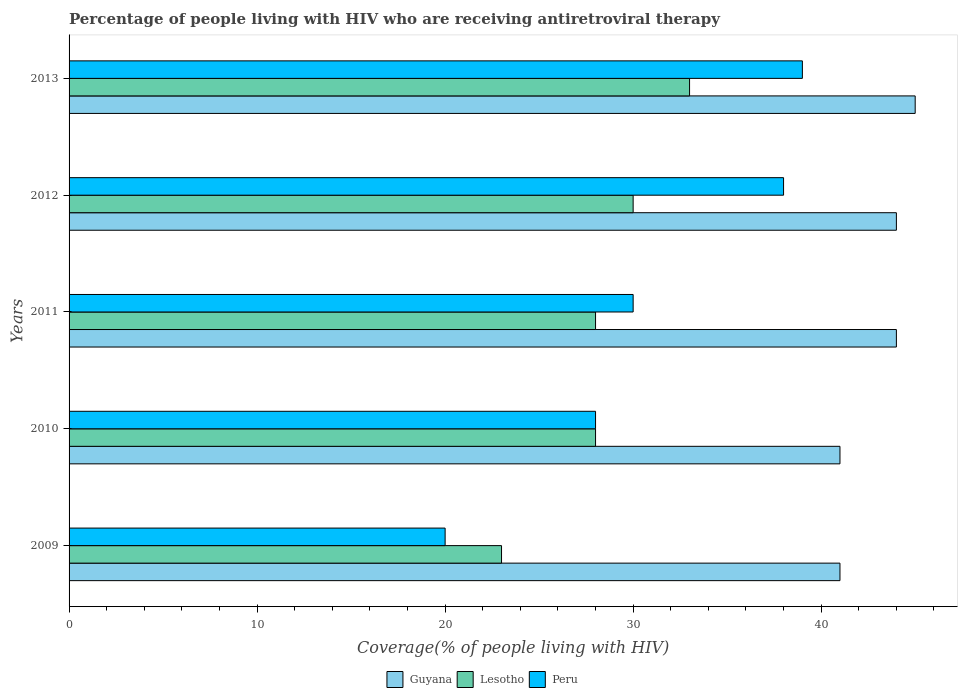How many different coloured bars are there?
Offer a very short reply. 3. What is the label of the 5th group of bars from the top?
Your answer should be compact. 2009. In how many cases, is the number of bars for a given year not equal to the number of legend labels?
Offer a terse response. 0. What is the percentage of the HIV infected people who are receiving antiretroviral therapy in Guyana in 2012?
Offer a terse response. 44. Across all years, what is the maximum percentage of the HIV infected people who are receiving antiretroviral therapy in Peru?
Your answer should be very brief. 39. Across all years, what is the minimum percentage of the HIV infected people who are receiving antiretroviral therapy in Guyana?
Provide a succinct answer. 41. In which year was the percentage of the HIV infected people who are receiving antiretroviral therapy in Lesotho maximum?
Offer a terse response. 2013. What is the total percentage of the HIV infected people who are receiving antiretroviral therapy in Lesotho in the graph?
Offer a terse response. 142. What is the difference between the percentage of the HIV infected people who are receiving antiretroviral therapy in Lesotho in 2011 and that in 2012?
Your response must be concise. -2. What is the difference between the percentage of the HIV infected people who are receiving antiretroviral therapy in Peru in 2009 and the percentage of the HIV infected people who are receiving antiretroviral therapy in Guyana in 2013?
Your answer should be compact. -25. What is the average percentage of the HIV infected people who are receiving antiretroviral therapy in Guyana per year?
Offer a very short reply. 43. In the year 2010, what is the difference between the percentage of the HIV infected people who are receiving antiretroviral therapy in Peru and percentage of the HIV infected people who are receiving antiretroviral therapy in Guyana?
Give a very brief answer. -13. In how many years, is the percentage of the HIV infected people who are receiving antiretroviral therapy in Lesotho greater than 12 %?
Your answer should be very brief. 5. What is the ratio of the percentage of the HIV infected people who are receiving antiretroviral therapy in Peru in 2010 to that in 2012?
Keep it short and to the point. 0.74. Is the difference between the percentage of the HIV infected people who are receiving antiretroviral therapy in Peru in 2009 and 2013 greater than the difference between the percentage of the HIV infected people who are receiving antiretroviral therapy in Guyana in 2009 and 2013?
Provide a short and direct response. No. What is the difference between the highest and the lowest percentage of the HIV infected people who are receiving antiretroviral therapy in Lesotho?
Provide a succinct answer. 10. In how many years, is the percentage of the HIV infected people who are receiving antiretroviral therapy in Peru greater than the average percentage of the HIV infected people who are receiving antiretroviral therapy in Peru taken over all years?
Give a very brief answer. 2. Is the sum of the percentage of the HIV infected people who are receiving antiretroviral therapy in Peru in 2009 and 2011 greater than the maximum percentage of the HIV infected people who are receiving antiretroviral therapy in Guyana across all years?
Ensure brevity in your answer.  Yes. What does the 1st bar from the top in 2011 represents?
Offer a very short reply. Peru. What does the 2nd bar from the bottom in 2012 represents?
Offer a terse response. Lesotho. What is the difference between two consecutive major ticks on the X-axis?
Provide a short and direct response. 10. Are the values on the major ticks of X-axis written in scientific E-notation?
Give a very brief answer. No. Does the graph contain any zero values?
Make the answer very short. No. Does the graph contain grids?
Offer a terse response. No. Where does the legend appear in the graph?
Your answer should be compact. Bottom center. How many legend labels are there?
Keep it short and to the point. 3. How are the legend labels stacked?
Your answer should be very brief. Horizontal. What is the title of the graph?
Offer a very short reply. Percentage of people living with HIV who are receiving antiretroviral therapy. Does "Kosovo" appear as one of the legend labels in the graph?
Your answer should be very brief. No. What is the label or title of the X-axis?
Ensure brevity in your answer.  Coverage(% of people living with HIV). What is the Coverage(% of people living with HIV) in Guyana in 2009?
Keep it short and to the point. 41. What is the Coverage(% of people living with HIV) of Peru in 2009?
Your response must be concise. 20. What is the Coverage(% of people living with HIV) of Guyana in 2010?
Give a very brief answer. 41. What is the Coverage(% of people living with HIV) of Guyana in 2012?
Make the answer very short. 44. What is the Coverage(% of people living with HIV) in Lesotho in 2012?
Provide a succinct answer. 30. What is the Coverage(% of people living with HIV) of Peru in 2013?
Your response must be concise. 39. Across all years, what is the maximum Coverage(% of people living with HIV) in Lesotho?
Ensure brevity in your answer.  33. Across all years, what is the minimum Coverage(% of people living with HIV) in Guyana?
Your answer should be very brief. 41. Across all years, what is the minimum Coverage(% of people living with HIV) of Lesotho?
Offer a very short reply. 23. Across all years, what is the minimum Coverage(% of people living with HIV) in Peru?
Make the answer very short. 20. What is the total Coverage(% of people living with HIV) of Guyana in the graph?
Provide a succinct answer. 215. What is the total Coverage(% of people living with HIV) in Lesotho in the graph?
Keep it short and to the point. 142. What is the total Coverage(% of people living with HIV) of Peru in the graph?
Keep it short and to the point. 155. What is the difference between the Coverage(% of people living with HIV) of Guyana in 2009 and that in 2010?
Your response must be concise. 0. What is the difference between the Coverage(% of people living with HIV) in Peru in 2009 and that in 2010?
Provide a short and direct response. -8. What is the difference between the Coverage(% of people living with HIV) in Lesotho in 2009 and that in 2011?
Offer a very short reply. -5. What is the difference between the Coverage(% of people living with HIV) of Peru in 2009 and that in 2011?
Your answer should be compact. -10. What is the difference between the Coverage(% of people living with HIV) in Guyana in 2009 and that in 2012?
Offer a terse response. -3. What is the difference between the Coverage(% of people living with HIV) in Peru in 2009 and that in 2012?
Your response must be concise. -18. What is the difference between the Coverage(% of people living with HIV) of Peru in 2009 and that in 2013?
Ensure brevity in your answer.  -19. What is the difference between the Coverage(% of people living with HIV) in Guyana in 2010 and that in 2011?
Provide a short and direct response. -3. What is the difference between the Coverage(% of people living with HIV) in Lesotho in 2010 and that in 2011?
Your answer should be very brief. 0. What is the difference between the Coverage(% of people living with HIV) of Lesotho in 2010 and that in 2013?
Provide a short and direct response. -5. What is the difference between the Coverage(% of people living with HIV) in Peru in 2010 and that in 2013?
Make the answer very short. -11. What is the difference between the Coverage(% of people living with HIV) of Lesotho in 2011 and that in 2012?
Make the answer very short. -2. What is the difference between the Coverage(% of people living with HIV) in Peru in 2011 and that in 2012?
Your answer should be compact. -8. What is the difference between the Coverage(% of people living with HIV) of Guyana in 2011 and that in 2013?
Offer a terse response. -1. What is the difference between the Coverage(% of people living with HIV) in Lesotho in 2011 and that in 2013?
Give a very brief answer. -5. What is the difference between the Coverage(% of people living with HIV) in Peru in 2011 and that in 2013?
Offer a terse response. -9. What is the difference between the Coverage(% of people living with HIV) of Guyana in 2009 and the Coverage(% of people living with HIV) of Peru in 2010?
Make the answer very short. 13. What is the difference between the Coverage(% of people living with HIV) of Lesotho in 2009 and the Coverage(% of people living with HIV) of Peru in 2010?
Make the answer very short. -5. What is the difference between the Coverage(% of people living with HIV) in Guyana in 2009 and the Coverage(% of people living with HIV) in Lesotho in 2011?
Your answer should be compact. 13. What is the difference between the Coverage(% of people living with HIV) of Lesotho in 2009 and the Coverage(% of people living with HIV) of Peru in 2011?
Offer a very short reply. -7. What is the difference between the Coverage(% of people living with HIV) of Guyana in 2009 and the Coverage(% of people living with HIV) of Lesotho in 2012?
Make the answer very short. 11. What is the difference between the Coverage(% of people living with HIV) in Guyana in 2009 and the Coverage(% of people living with HIV) in Lesotho in 2013?
Offer a terse response. 8. What is the difference between the Coverage(% of people living with HIV) in Guyana in 2009 and the Coverage(% of people living with HIV) in Peru in 2013?
Offer a very short reply. 2. What is the difference between the Coverage(% of people living with HIV) of Lesotho in 2009 and the Coverage(% of people living with HIV) of Peru in 2013?
Your response must be concise. -16. What is the difference between the Coverage(% of people living with HIV) in Guyana in 2010 and the Coverage(% of people living with HIV) in Lesotho in 2011?
Provide a succinct answer. 13. What is the difference between the Coverage(% of people living with HIV) of Guyana in 2010 and the Coverage(% of people living with HIV) of Peru in 2011?
Ensure brevity in your answer.  11. What is the difference between the Coverage(% of people living with HIV) of Guyana in 2010 and the Coverage(% of people living with HIV) of Lesotho in 2012?
Provide a succinct answer. 11. What is the difference between the Coverage(% of people living with HIV) of Guyana in 2010 and the Coverage(% of people living with HIV) of Peru in 2012?
Ensure brevity in your answer.  3. What is the difference between the Coverage(% of people living with HIV) in Lesotho in 2010 and the Coverage(% of people living with HIV) in Peru in 2013?
Offer a very short reply. -11. What is the difference between the Coverage(% of people living with HIV) in Guyana in 2011 and the Coverage(% of people living with HIV) in Peru in 2012?
Your answer should be compact. 6. What is the difference between the Coverage(% of people living with HIV) of Lesotho in 2011 and the Coverage(% of people living with HIV) of Peru in 2012?
Provide a succinct answer. -10. What is the difference between the Coverage(% of people living with HIV) of Guyana in 2012 and the Coverage(% of people living with HIV) of Lesotho in 2013?
Your response must be concise. 11. What is the difference between the Coverage(% of people living with HIV) in Guyana in 2012 and the Coverage(% of people living with HIV) in Peru in 2013?
Give a very brief answer. 5. What is the average Coverage(% of people living with HIV) of Guyana per year?
Provide a succinct answer. 43. What is the average Coverage(% of people living with HIV) in Lesotho per year?
Keep it short and to the point. 28.4. What is the average Coverage(% of people living with HIV) in Peru per year?
Provide a succinct answer. 31. In the year 2009, what is the difference between the Coverage(% of people living with HIV) in Guyana and Coverage(% of people living with HIV) in Lesotho?
Your answer should be very brief. 18. In the year 2009, what is the difference between the Coverage(% of people living with HIV) in Guyana and Coverage(% of people living with HIV) in Peru?
Give a very brief answer. 21. In the year 2010, what is the difference between the Coverage(% of people living with HIV) of Guyana and Coverage(% of people living with HIV) of Lesotho?
Your response must be concise. 13. In the year 2010, what is the difference between the Coverage(% of people living with HIV) of Guyana and Coverage(% of people living with HIV) of Peru?
Your response must be concise. 13. In the year 2010, what is the difference between the Coverage(% of people living with HIV) of Lesotho and Coverage(% of people living with HIV) of Peru?
Provide a short and direct response. 0. In the year 2012, what is the difference between the Coverage(% of people living with HIV) of Guyana and Coverage(% of people living with HIV) of Lesotho?
Give a very brief answer. 14. In the year 2012, what is the difference between the Coverage(% of people living with HIV) of Lesotho and Coverage(% of people living with HIV) of Peru?
Your answer should be compact. -8. In the year 2013, what is the difference between the Coverage(% of people living with HIV) in Guyana and Coverage(% of people living with HIV) in Peru?
Offer a terse response. 6. In the year 2013, what is the difference between the Coverage(% of people living with HIV) of Lesotho and Coverage(% of people living with HIV) of Peru?
Your response must be concise. -6. What is the ratio of the Coverage(% of people living with HIV) of Lesotho in 2009 to that in 2010?
Ensure brevity in your answer.  0.82. What is the ratio of the Coverage(% of people living with HIV) in Peru in 2009 to that in 2010?
Offer a terse response. 0.71. What is the ratio of the Coverage(% of people living with HIV) in Guyana in 2009 to that in 2011?
Provide a succinct answer. 0.93. What is the ratio of the Coverage(% of people living with HIV) of Lesotho in 2009 to that in 2011?
Offer a very short reply. 0.82. What is the ratio of the Coverage(% of people living with HIV) in Guyana in 2009 to that in 2012?
Give a very brief answer. 0.93. What is the ratio of the Coverage(% of people living with HIV) of Lesotho in 2009 to that in 2012?
Keep it short and to the point. 0.77. What is the ratio of the Coverage(% of people living with HIV) of Peru in 2009 to that in 2012?
Provide a succinct answer. 0.53. What is the ratio of the Coverage(% of people living with HIV) of Guyana in 2009 to that in 2013?
Provide a short and direct response. 0.91. What is the ratio of the Coverage(% of people living with HIV) in Lesotho in 2009 to that in 2013?
Make the answer very short. 0.7. What is the ratio of the Coverage(% of people living with HIV) in Peru in 2009 to that in 2013?
Your response must be concise. 0.51. What is the ratio of the Coverage(% of people living with HIV) of Guyana in 2010 to that in 2011?
Your answer should be very brief. 0.93. What is the ratio of the Coverage(% of people living with HIV) in Lesotho in 2010 to that in 2011?
Ensure brevity in your answer.  1. What is the ratio of the Coverage(% of people living with HIV) in Guyana in 2010 to that in 2012?
Your answer should be compact. 0.93. What is the ratio of the Coverage(% of people living with HIV) in Lesotho in 2010 to that in 2012?
Make the answer very short. 0.93. What is the ratio of the Coverage(% of people living with HIV) in Peru in 2010 to that in 2012?
Your answer should be compact. 0.74. What is the ratio of the Coverage(% of people living with HIV) of Guyana in 2010 to that in 2013?
Provide a succinct answer. 0.91. What is the ratio of the Coverage(% of people living with HIV) of Lesotho in 2010 to that in 2013?
Make the answer very short. 0.85. What is the ratio of the Coverage(% of people living with HIV) in Peru in 2010 to that in 2013?
Provide a succinct answer. 0.72. What is the ratio of the Coverage(% of people living with HIV) of Guyana in 2011 to that in 2012?
Provide a short and direct response. 1. What is the ratio of the Coverage(% of people living with HIV) in Peru in 2011 to that in 2012?
Keep it short and to the point. 0.79. What is the ratio of the Coverage(% of people living with HIV) in Guyana in 2011 to that in 2013?
Provide a succinct answer. 0.98. What is the ratio of the Coverage(% of people living with HIV) of Lesotho in 2011 to that in 2013?
Provide a succinct answer. 0.85. What is the ratio of the Coverage(% of people living with HIV) in Peru in 2011 to that in 2013?
Your answer should be compact. 0.77. What is the ratio of the Coverage(% of people living with HIV) in Guyana in 2012 to that in 2013?
Offer a very short reply. 0.98. What is the ratio of the Coverage(% of people living with HIV) of Lesotho in 2012 to that in 2013?
Offer a terse response. 0.91. What is the ratio of the Coverage(% of people living with HIV) of Peru in 2012 to that in 2013?
Your answer should be compact. 0.97. What is the difference between the highest and the second highest Coverage(% of people living with HIV) in Guyana?
Make the answer very short. 1. What is the difference between the highest and the lowest Coverage(% of people living with HIV) in Guyana?
Provide a succinct answer. 4. What is the difference between the highest and the lowest Coverage(% of people living with HIV) in Lesotho?
Offer a terse response. 10. 